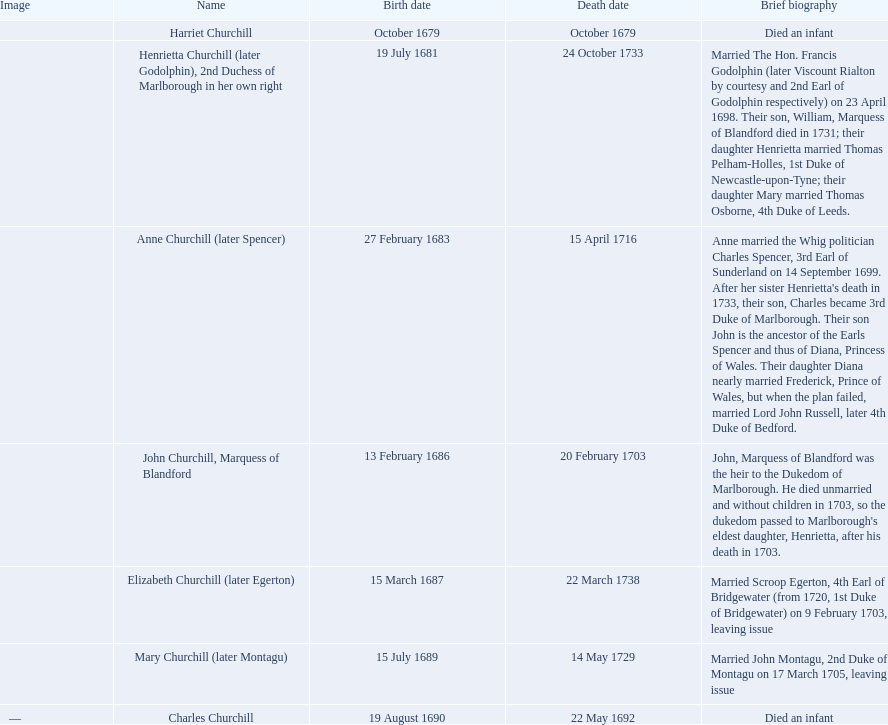What is the total number of children born after 1675? 7. 